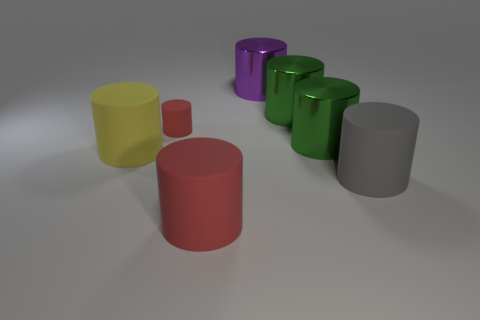How many objects are either large cylinders that are to the right of the big purple metallic thing or things right of the large red matte thing?
Offer a terse response. 4. Are there more green things that are to the left of the big purple object than small green spheres?
Ensure brevity in your answer.  No. How many other things are there of the same shape as the yellow matte object?
Provide a succinct answer. 6. The big cylinder that is behind the big red cylinder and in front of the yellow cylinder is made of what material?
Keep it short and to the point. Rubber. How many things are large green cylinders or red things?
Keep it short and to the point. 4. Is the number of green things greater than the number of small red balls?
Offer a terse response. Yes. There is a red object left of the red cylinder that is in front of the big yellow matte cylinder; what is its size?
Your response must be concise. Small. How big is the purple metallic object?
Your response must be concise. Large. How many cylinders are yellow matte things or large gray rubber objects?
Your answer should be very brief. 2. What is the size of the purple metal object that is the same shape as the tiny red rubber object?
Provide a succinct answer. Large. 